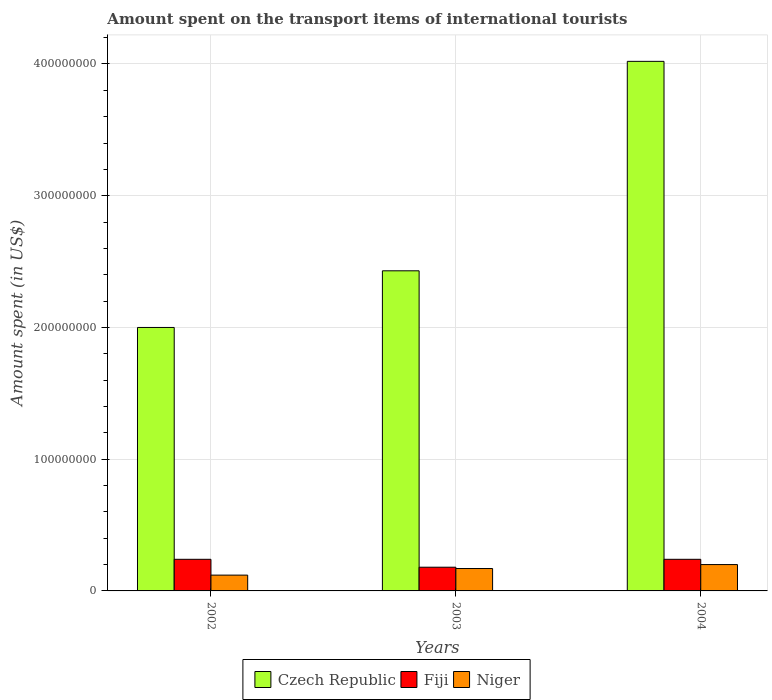How many groups of bars are there?
Provide a succinct answer. 3. Are the number of bars on each tick of the X-axis equal?
Provide a short and direct response. Yes. What is the amount spent on the transport items of international tourists in Fiji in 2004?
Give a very brief answer. 2.40e+07. Across all years, what is the maximum amount spent on the transport items of international tourists in Czech Republic?
Provide a short and direct response. 4.02e+08. Across all years, what is the minimum amount spent on the transport items of international tourists in Niger?
Your answer should be compact. 1.20e+07. In which year was the amount spent on the transport items of international tourists in Niger maximum?
Make the answer very short. 2004. What is the total amount spent on the transport items of international tourists in Czech Republic in the graph?
Your answer should be compact. 8.45e+08. What is the difference between the amount spent on the transport items of international tourists in Czech Republic in 2003 and that in 2004?
Offer a very short reply. -1.59e+08. What is the difference between the amount spent on the transport items of international tourists in Czech Republic in 2003 and the amount spent on the transport items of international tourists in Niger in 2002?
Your answer should be compact. 2.31e+08. What is the average amount spent on the transport items of international tourists in Czech Republic per year?
Offer a very short reply. 2.82e+08. In the year 2003, what is the difference between the amount spent on the transport items of international tourists in Czech Republic and amount spent on the transport items of international tourists in Fiji?
Your answer should be compact. 2.25e+08. What is the difference between the highest and the second highest amount spent on the transport items of international tourists in Czech Republic?
Provide a short and direct response. 1.59e+08. What is the difference between the highest and the lowest amount spent on the transport items of international tourists in Fiji?
Keep it short and to the point. 6.00e+06. In how many years, is the amount spent on the transport items of international tourists in Fiji greater than the average amount spent on the transport items of international tourists in Fiji taken over all years?
Provide a succinct answer. 2. What does the 2nd bar from the left in 2004 represents?
Keep it short and to the point. Fiji. What does the 2nd bar from the right in 2003 represents?
Keep it short and to the point. Fiji. Is it the case that in every year, the sum of the amount spent on the transport items of international tourists in Fiji and amount spent on the transport items of international tourists in Czech Republic is greater than the amount spent on the transport items of international tourists in Niger?
Provide a succinct answer. Yes. How many years are there in the graph?
Your answer should be compact. 3. Are the values on the major ticks of Y-axis written in scientific E-notation?
Provide a short and direct response. No. Does the graph contain grids?
Offer a terse response. Yes. How are the legend labels stacked?
Your answer should be compact. Horizontal. What is the title of the graph?
Keep it short and to the point. Amount spent on the transport items of international tourists. Does "Haiti" appear as one of the legend labels in the graph?
Keep it short and to the point. No. What is the label or title of the X-axis?
Keep it short and to the point. Years. What is the label or title of the Y-axis?
Offer a terse response. Amount spent (in US$). What is the Amount spent (in US$) of Czech Republic in 2002?
Your response must be concise. 2.00e+08. What is the Amount spent (in US$) of Fiji in 2002?
Make the answer very short. 2.40e+07. What is the Amount spent (in US$) of Czech Republic in 2003?
Ensure brevity in your answer.  2.43e+08. What is the Amount spent (in US$) in Fiji in 2003?
Ensure brevity in your answer.  1.80e+07. What is the Amount spent (in US$) in Niger in 2003?
Provide a short and direct response. 1.70e+07. What is the Amount spent (in US$) of Czech Republic in 2004?
Ensure brevity in your answer.  4.02e+08. What is the Amount spent (in US$) of Fiji in 2004?
Offer a terse response. 2.40e+07. What is the Amount spent (in US$) of Niger in 2004?
Keep it short and to the point. 2.00e+07. Across all years, what is the maximum Amount spent (in US$) of Czech Republic?
Your answer should be very brief. 4.02e+08. Across all years, what is the maximum Amount spent (in US$) in Fiji?
Your response must be concise. 2.40e+07. Across all years, what is the maximum Amount spent (in US$) of Niger?
Your response must be concise. 2.00e+07. Across all years, what is the minimum Amount spent (in US$) in Fiji?
Make the answer very short. 1.80e+07. Across all years, what is the minimum Amount spent (in US$) of Niger?
Your answer should be very brief. 1.20e+07. What is the total Amount spent (in US$) of Czech Republic in the graph?
Keep it short and to the point. 8.45e+08. What is the total Amount spent (in US$) of Fiji in the graph?
Keep it short and to the point. 6.60e+07. What is the total Amount spent (in US$) in Niger in the graph?
Your answer should be very brief. 4.90e+07. What is the difference between the Amount spent (in US$) in Czech Republic in 2002 and that in 2003?
Give a very brief answer. -4.30e+07. What is the difference between the Amount spent (in US$) of Niger in 2002 and that in 2003?
Make the answer very short. -5.00e+06. What is the difference between the Amount spent (in US$) in Czech Republic in 2002 and that in 2004?
Your response must be concise. -2.02e+08. What is the difference between the Amount spent (in US$) of Niger in 2002 and that in 2004?
Ensure brevity in your answer.  -8.00e+06. What is the difference between the Amount spent (in US$) of Czech Republic in 2003 and that in 2004?
Offer a very short reply. -1.59e+08. What is the difference between the Amount spent (in US$) of Fiji in 2003 and that in 2004?
Ensure brevity in your answer.  -6.00e+06. What is the difference between the Amount spent (in US$) in Niger in 2003 and that in 2004?
Offer a very short reply. -3.00e+06. What is the difference between the Amount spent (in US$) in Czech Republic in 2002 and the Amount spent (in US$) in Fiji in 2003?
Ensure brevity in your answer.  1.82e+08. What is the difference between the Amount spent (in US$) in Czech Republic in 2002 and the Amount spent (in US$) in Niger in 2003?
Make the answer very short. 1.83e+08. What is the difference between the Amount spent (in US$) of Fiji in 2002 and the Amount spent (in US$) of Niger in 2003?
Give a very brief answer. 7.00e+06. What is the difference between the Amount spent (in US$) of Czech Republic in 2002 and the Amount spent (in US$) of Fiji in 2004?
Offer a terse response. 1.76e+08. What is the difference between the Amount spent (in US$) in Czech Republic in 2002 and the Amount spent (in US$) in Niger in 2004?
Your answer should be very brief. 1.80e+08. What is the difference between the Amount spent (in US$) in Fiji in 2002 and the Amount spent (in US$) in Niger in 2004?
Provide a short and direct response. 4.00e+06. What is the difference between the Amount spent (in US$) of Czech Republic in 2003 and the Amount spent (in US$) of Fiji in 2004?
Give a very brief answer. 2.19e+08. What is the difference between the Amount spent (in US$) of Czech Republic in 2003 and the Amount spent (in US$) of Niger in 2004?
Provide a succinct answer. 2.23e+08. What is the difference between the Amount spent (in US$) in Fiji in 2003 and the Amount spent (in US$) in Niger in 2004?
Offer a terse response. -2.00e+06. What is the average Amount spent (in US$) in Czech Republic per year?
Provide a succinct answer. 2.82e+08. What is the average Amount spent (in US$) in Fiji per year?
Offer a terse response. 2.20e+07. What is the average Amount spent (in US$) in Niger per year?
Offer a very short reply. 1.63e+07. In the year 2002, what is the difference between the Amount spent (in US$) of Czech Republic and Amount spent (in US$) of Fiji?
Keep it short and to the point. 1.76e+08. In the year 2002, what is the difference between the Amount spent (in US$) of Czech Republic and Amount spent (in US$) of Niger?
Provide a succinct answer. 1.88e+08. In the year 2003, what is the difference between the Amount spent (in US$) in Czech Republic and Amount spent (in US$) in Fiji?
Your response must be concise. 2.25e+08. In the year 2003, what is the difference between the Amount spent (in US$) in Czech Republic and Amount spent (in US$) in Niger?
Your response must be concise. 2.26e+08. In the year 2004, what is the difference between the Amount spent (in US$) in Czech Republic and Amount spent (in US$) in Fiji?
Keep it short and to the point. 3.78e+08. In the year 2004, what is the difference between the Amount spent (in US$) of Czech Republic and Amount spent (in US$) of Niger?
Your response must be concise. 3.82e+08. What is the ratio of the Amount spent (in US$) of Czech Republic in 2002 to that in 2003?
Give a very brief answer. 0.82. What is the ratio of the Amount spent (in US$) of Fiji in 2002 to that in 2003?
Keep it short and to the point. 1.33. What is the ratio of the Amount spent (in US$) of Niger in 2002 to that in 2003?
Provide a succinct answer. 0.71. What is the ratio of the Amount spent (in US$) of Czech Republic in 2002 to that in 2004?
Provide a short and direct response. 0.5. What is the ratio of the Amount spent (in US$) in Niger in 2002 to that in 2004?
Your answer should be very brief. 0.6. What is the ratio of the Amount spent (in US$) in Czech Republic in 2003 to that in 2004?
Give a very brief answer. 0.6. What is the ratio of the Amount spent (in US$) in Fiji in 2003 to that in 2004?
Provide a succinct answer. 0.75. What is the difference between the highest and the second highest Amount spent (in US$) of Czech Republic?
Offer a terse response. 1.59e+08. What is the difference between the highest and the lowest Amount spent (in US$) in Czech Republic?
Give a very brief answer. 2.02e+08. What is the difference between the highest and the lowest Amount spent (in US$) of Fiji?
Provide a succinct answer. 6.00e+06. 